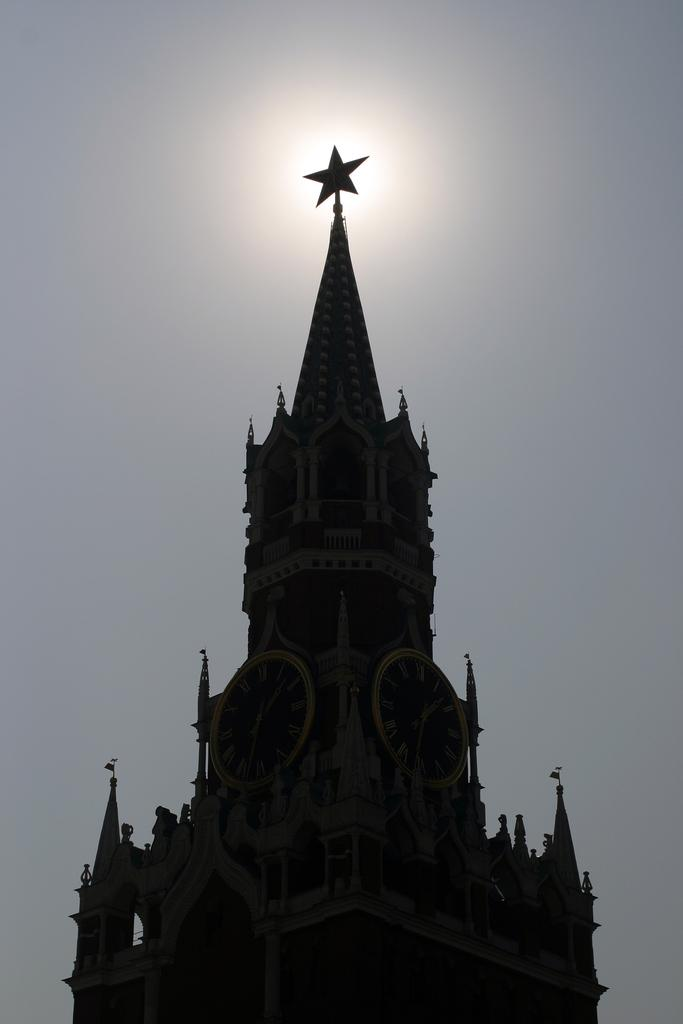What is the main structure in the image? There is a building in the image. What feature can be seen on the building? There are clocks on the building. What is visible at the top of the image? The sky is visible at the top of the image. How many mice can be seen running on the clocks in the image? There are no mice present in the image; it only features a building with clocks. 